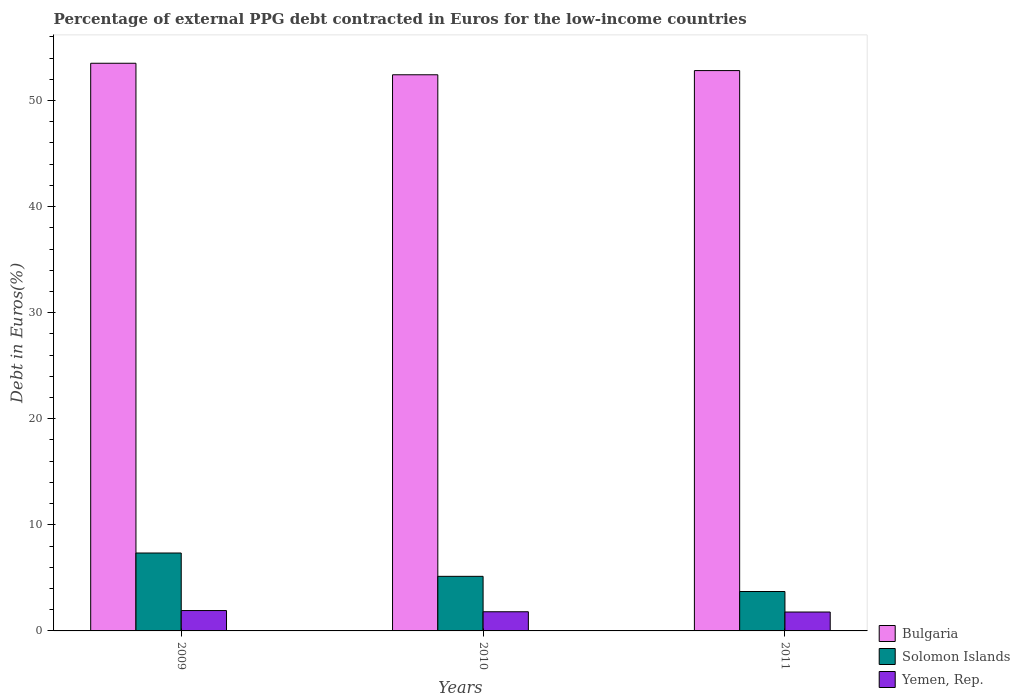Are the number of bars per tick equal to the number of legend labels?
Provide a short and direct response. Yes. How many bars are there on the 2nd tick from the right?
Give a very brief answer. 3. What is the label of the 1st group of bars from the left?
Provide a short and direct response. 2009. In how many cases, is the number of bars for a given year not equal to the number of legend labels?
Provide a short and direct response. 0. What is the percentage of external PPG debt contracted in Euros in Solomon Islands in 2009?
Your response must be concise. 7.34. Across all years, what is the maximum percentage of external PPG debt contracted in Euros in Yemen, Rep.?
Your response must be concise. 1.92. Across all years, what is the minimum percentage of external PPG debt contracted in Euros in Solomon Islands?
Provide a succinct answer. 3.72. In which year was the percentage of external PPG debt contracted in Euros in Solomon Islands maximum?
Make the answer very short. 2009. In which year was the percentage of external PPG debt contracted in Euros in Bulgaria minimum?
Your response must be concise. 2010. What is the total percentage of external PPG debt contracted in Euros in Bulgaria in the graph?
Offer a very short reply. 158.75. What is the difference between the percentage of external PPG debt contracted in Euros in Bulgaria in 2009 and that in 2011?
Make the answer very short. 0.69. What is the difference between the percentage of external PPG debt contracted in Euros in Bulgaria in 2010 and the percentage of external PPG debt contracted in Euros in Yemen, Rep. in 2009?
Give a very brief answer. 50.5. What is the average percentage of external PPG debt contracted in Euros in Bulgaria per year?
Ensure brevity in your answer.  52.92. In the year 2011, what is the difference between the percentage of external PPG debt contracted in Euros in Yemen, Rep. and percentage of external PPG debt contracted in Euros in Bulgaria?
Provide a short and direct response. -51.04. In how many years, is the percentage of external PPG debt contracted in Euros in Solomon Islands greater than 50 %?
Your answer should be compact. 0. What is the ratio of the percentage of external PPG debt contracted in Euros in Yemen, Rep. in 2009 to that in 2010?
Ensure brevity in your answer.  1.06. Is the percentage of external PPG debt contracted in Euros in Yemen, Rep. in 2010 less than that in 2011?
Ensure brevity in your answer.  No. Is the difference between the percentage of external PPG debt contracted in Euros in Yemen, Rep. in 2010 and 2011 greater than the difference between the percentage of external PPG debt contracted in Euros in Bulgaria in 2010 and 2011?
Make the answer very short. Yes. What is the difference between the highest and the second highest percentage of external PPG debt contracted in Euros in Yemen, Rep.?
Offer a terse response. 0.11. What is the difference between the highest and the lowest percentage of external PPG debt contracted in Euros in Yemen, Rep.?
Your response must be concise. 0.14. Is the sum of the percentage of external PPG debt contracted in Euros in Bulgaria in 2010 and 2011 greater than the maximum percentage of external PPG debt contracted in Euros in Solomon Islands across all years?
Your answer should be compact. Yes. What does the 3rd bar from the left in 2009 represents?
Your answer should be compact. Yemen, Rep. What does the 2nd bar from the right in 2010 represents?
Your response must be concise. Solomon Islands. Is it the case that in every year, the sum of the percentage of external PPG debt contracted in Euros in Solomon Islands and percentage of external PPG debt contracted in Euros in Bulgaria is greater than the percentage of external PPG debt contracted in Euros in Yemen, Rep.?
Provide a short and direct response. Yes. How many bars are there?
Your answer should be compact. 9. Are all the bars in the graph horizontal?
Your response must be concise. No. How many years are there in the graph?
Give a very brief answer. 3. What is the difference between two consecutive major ticks on the Y-axis?
Give a very brief answer. 10. Are the values on the major ticks of Y-axis written in scientific E-notation?
Offer a terse response. No. Does the graph contain any zero values?
Keep it short and to the point. No. Does the graph contain grids?
Keep it short and to the point. No. How many legend labels are there?
Provide a succinct answer. 3. How are the legend labels stacked?
Give a very brief answer. Vertical. What is the title of the graph?
Provide a succinct answer. Percentage of external PPG debt contracted in Euros for the low-income countries. Does "United Arab Emirates" appear as one of the legend labels in the graph?
Offer a very short reply. No. What is the label or title of the Y-axis?
Ensure brevity in your answer.  Debt in Euros(%). What is the Debt in Euros(%) in Bulgaria in 2009?
Offer a very short reply. 53.51. What is the Debt in Euros(%) of Solomon Islands in 2009?
Offer a very short reply. 7.34. What is the Debt in Euros(%) of Yemen, Rep. in 2009?
Keep it short and to the point. 1.92. What is the Debt in Euros(%) of Bulgaria in 2010?
Make the answer very short. 52.42. What is the Debt in Euros(%) of Solomon Islands in 2010?
Make the answer very short. 5.15. What is the Debt in Euros(%) of Yemen, Rep. in 2010?
Give a very brief answer. 1.81. What is the Debt in Euros(%) in Bulgaria in 2011?
Provide a succinct answer. 52.82. What is the Debt in Euros(%) in Solomon Islands in 2011?
Offer a very short reply. 3.72. What is the Debt in Euros(%) in Yemen, Rep. in 2011?
Offer a very short reply. 1.78. Across all years, what is the maximum Debt in Euros(%) in Bulgaria?
Ensure brevity in your answer.  53.51. Across all years, what is the maximum Debt in Euros(%) in Solomon Islands?
Your answer should be very brief. 7.34. Across all years, what is the maximum Debt in Euros(%) of Yemen, Rep.?
Your response must be concise. 1.92. Across all years, what is the minimum Debt in Euros(%) in Bulgaria?
Your answer should be compact. 52.42. Across all years, what is the minimum Debt in Euros(%) in Solomon Islands?
Provide a succinct answer. 3.72. Across all years, what is the minimum Debt in Euros(%) in Yemen, Rep.?
Your response must be concise. 1.78. What is the total Debt in Euros(%) in Bulgaria in the graph?
Ensure brevity in your answer.  158.75. What is the total Debt in Euros(%) in Solomon Islands in the graph?
Your response must be concise. 16.21. What is the total Debt in Euros(%) of Yemen, Rep. in the graph?
Give a very brief answer. 5.51. What is the difference between the Debt in Euros(%) of Bulgaria in 2009 and that in 2010?
Keep it short and to the point. 1.09. What is the difference between the Debt in Euros(%) of Solomon Islands in 2009 and that in 2010?
Make the answer very short. 2.2. What is the difference between the Debt in Euros(%) of Yemen, Rep. in 2009 and that in 2010?
Ensure brevity in your answer.  0.11. What is the difference between the Debt in Euros(%) of Bulgaria in 2009 and that in 2011?
Offer a terse response. 0.69. What is the difference between the Debt in Euros(%) in Solomon Islands in 2009 and that in 2011?
Provide a succinct answer. 3.63. What is the difference between the Debt in Euros(%) of Yemen, Rep. in 2009 and that in 2011?
Ensure brevity in your answer.  0.14. What is the difference between the Debt in Euros(%) of Bulgaria in 2010 and that in 2011?
Keep it short and to the point. -0.4. What is the difference between the Debt in Euros(%) in Solomon Islands in 2010 and that in 2011?
Offer a very short reply. 1.43. What is the difference between the Debt in Euros(%) in Yemen, Rep. in 2010 and that in 2011?
Your answer should be very brief. 0.03. What is the difference between the Debt in Euros(%) in Bulgaria in 2009 and the Debt in Euros(%) in Solomon Islands in 2010?
Provide a short and direct response. 48.36. What is the difference between the Debt in Euros(%) of Bulgaria in 2009 and the Debt in Euros(%) of Yemen, Rep. in 2010?
Keep it short and to the point. 51.7. What is the difference between the Debt in Euros(%) in Solomon Islands in 2009 and the Debt in Euros(%) in Yemen, Rep. in 2010?
Offer a terse response. 5.54. What is the difference between the Debt in Euros(%) of Bulgaria in 2009 and the Debt in Euros(%) of Solomon Islands in 2011?
Keep it short and to the point. 49.79. What is the difference between the Debt in Euros(%) of Bulgaria in 2009 and the Debt in Euros(%) of Yemen, Rep. in 2011?
Ensure brevity in your answer.  51.73. What is the difference between the Debt in Euros(%) of Solomon Islands in 2009 and the Debt in Euros(%) of Yemen, Rep. in 2011?
Your response must be concise. 5.56. What is the difference between the Debt in Euros(%) of Bulgaria in 2010 and the Debt in Euros(%) of Solomon Islands in 2011?
Give a very brief answer. 48.71. What is the difference between the Debt in Euros(%) of Bulgaria in 2010 and the Debt in Euros(%) of Yemen, Rep. in 2011?
Offer a very short reply. 50.64. What is the difference between the Debt in Euros(%) in Solomon Islands in 2010 and the Debt in Euros(%) in Yemen, Rep. in 2011?
Your answer should be compact. 3.36. What is the average Debt in Euros(%) of Bulgaria per year?
Your answer should be compact. 52.92. What is the average Debt in Euros(%) of Solomon Islands per year?
Your response must be concise. 5.4. What is the average Debt in Euros(%) in Yemen, Rep. per year?
Your response must be concise. 1.84. In the year 2009, what is the difference between the Debt in Euros(%) of Bulgaria and Debt in Euros(%) of Solomon Islands?
Ensure brevity in your answer.  46.16. In the year 2009, what is the difference between the Debt in Euros(%) of Bulgaria and Debt in Euros(%) of Yemen, Rep.?
Provide a succinct answer. 51.59. In the year 2009, what is the difference between the Debt in Euros(%) in Solomon Islands and Debt in Euros(%) in Yemen, Rep.?
Keep it short and to the point. 5.43. In the year 2010, what is the difference between the Debt in Euros(%) of Bulgaria and Debt in Euros(%) of Solomon Islands?
Provide a succinct answer. 47.28. In the year 2010, what is the difference between the Debt in Euros(%) in Bulgaria and Debt in Euros(%) in Yemen, Rep.?
Your answer should be very brief. 50.62. In the year 2010, what is the difference between the Debt in Euros(%) of Solomon Islands and Debt in Euros(%) of Yemen, Rep.?
Offer a terse response. 3.34. In the year 2011, what is the difference between the Debt in Euros(%) in Bulgaria and Debt in Euros(%) in Solomon Islands?
Make the answer very short. 49.1. In the year 2011, what is the difference between the Debt in Euros(%) of Bulgaria and Debt in Euros(%) of Yemen, Rep.?
Make the answer very short. 51.04. In the year 2011, what is the difference between the Debt in Euros(%) in Solomon Islands and Debt in Euros(%) in Yemen, Rep.?
Provide a succinct answer. 1.93. What is the ratio of the Debt in Euros(%) in Bulgaria in 2009 to that in 2010?
Ensure brevity in your answer.  1.02. What is the ratio of the Debt in Euros(%) of Solomon Islands in 2009 to that in 2010?
Provide a succinct answer. 1.43. What is the ratio of the Debt in Euros(%) in Yemen, Rep. in 2009 to that in 2010?
Your response must be concise. 1.06. What is the ratio of the Debt in Euros(%) in Bulgaria in 2009 to that in 2011?
Offer a very short reply. 1.01. What is the ratio of the Debt in Euros(%) of Solomon Islands in 2009 to that in 2011?
Make the answer very short. 1.98. What is the ratio of the Debt in Euros(%) in Yemen, Rep. in 2009 to that in 2011?
Your response must be concise. 1.08. What is the ratio of the Debt in Euros(%) in Solomon Islands in 2010 to that in 2011?
Keep it short and to the point. 1.38. What is the ratio of the Debt in Euros(%) in Yemen, Rep. in 2010 to that in 2011?
Your answer should be compact. 1.01. What is the difference between the highest and the second highest Debt in Euros(%) in Bulgaria?
Offer a very short reply. 0.69. What is the difference between the highest and the second highest Debt in Euros(%) in Solomon Islands?
Keep it short and to the point. 2.2. What is the difference between the highest and the second highest Debt in Euros(%) of Yemen, Rep.?
Your answer should be very brief. 0.11. What is the difference between the highest and the lowest Debt in Euros(%) in Bulgaria?
Offer a terse response. 1.09. What is the difference between the highest and the lowest Debt in Euros(%) of Solomon Islands?
Provide a short and direct response. 3.63. What is the difference between the highest and the lowest Debt in Euros(%) of Yemen, Rep.?
Make the answer very short. 0.14. 